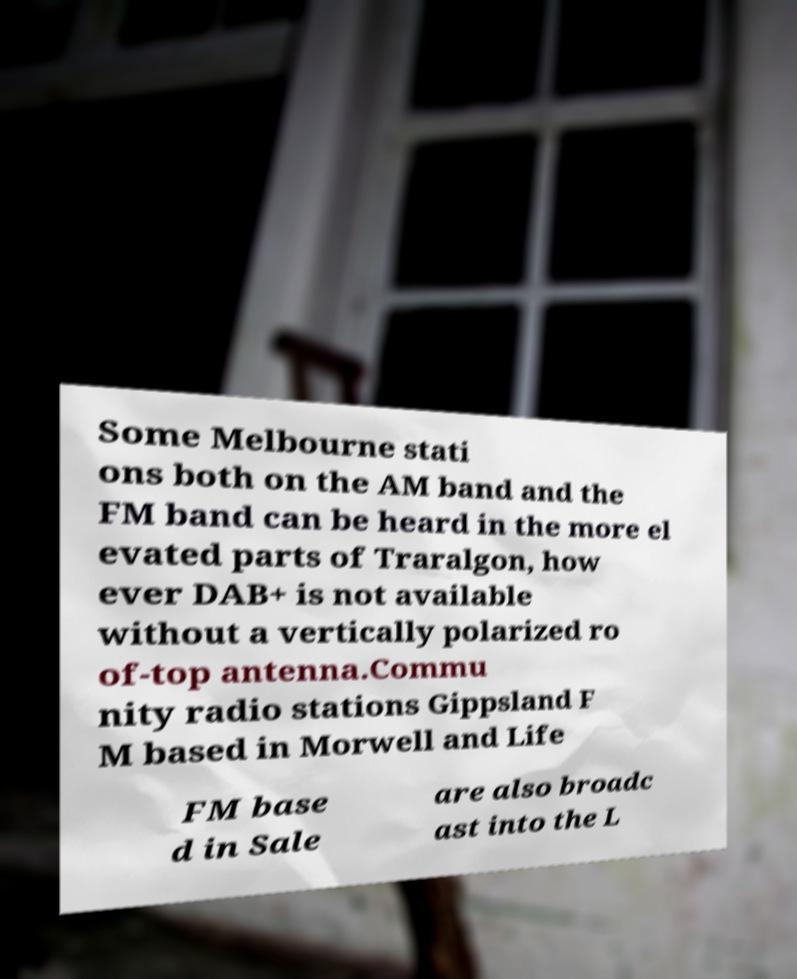What messages or text are displayed in this image? I need them in a readable, typed format. Some Melbourne stati ons both on the AM band and the FM band can be heard in the more el evated parts of Traralgon, how ever DAB+ is not available without a vertically polarized ro of-top antenna.Commu nity radio stations Gippsland F M based in Morwell and Life FM base d in Sale are also broadc ast into the L 